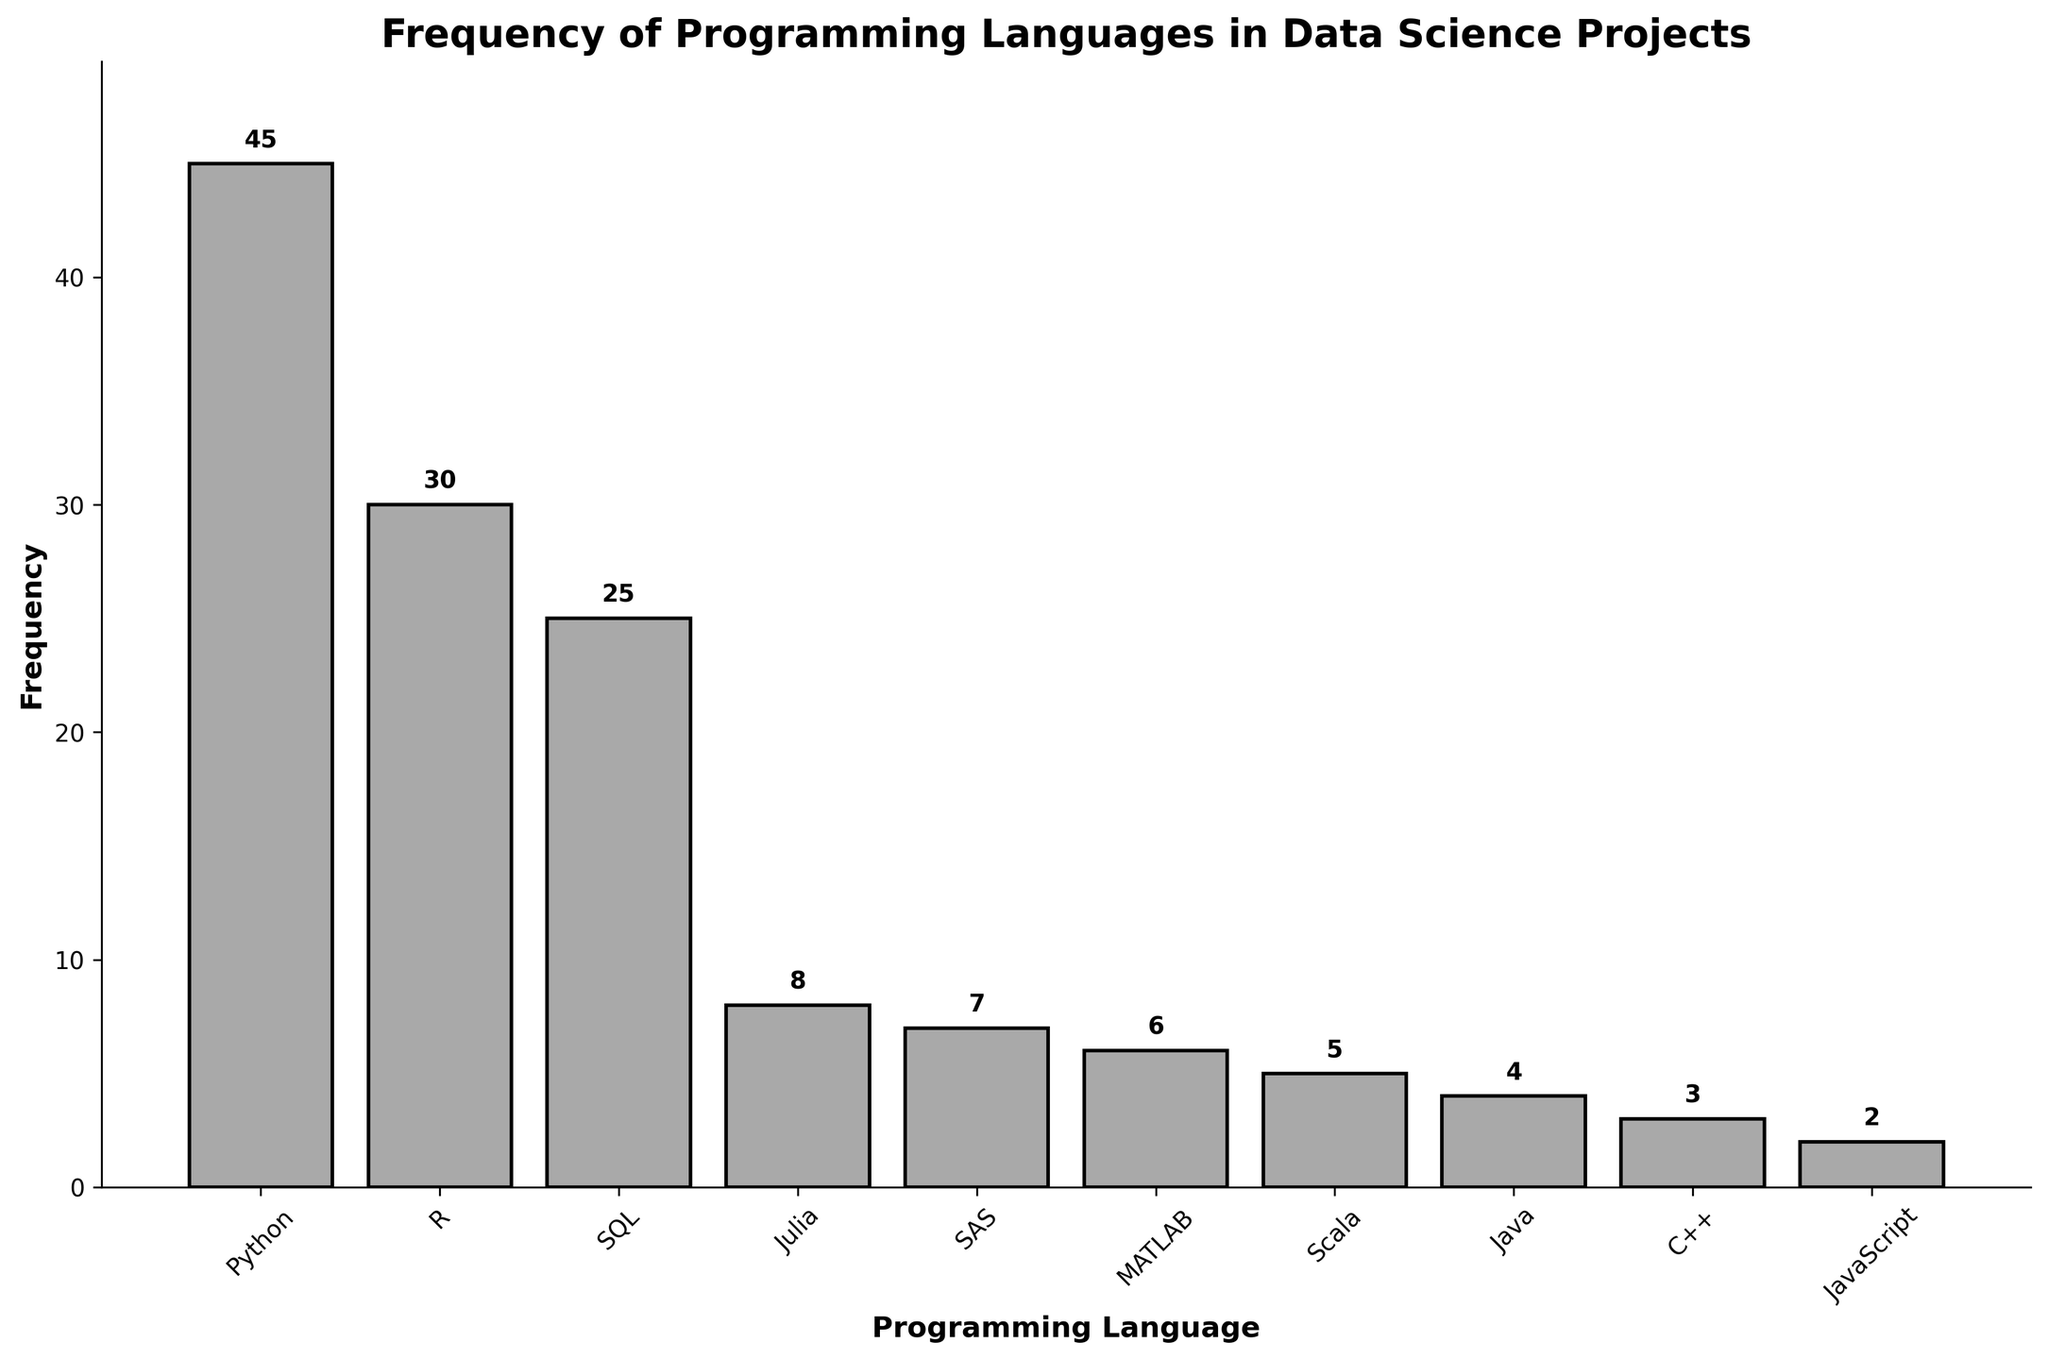What is the title of the histogram? Read the title text at the top of the histogram, which describes the content of the chart.
Answer: Frequency of Programming Languages in Data Science Projects How many programming languages are represented in the histogram? Count the number of different bars shown on the x-axis, each representing a programming language.
Answer: 10 Which programming language has the highest frequency? Look for the tallest bar in the histogram and read the corresponding programming language label on the x-axis.
Answer: Python What is the frequency of Java? Find the bar labeled "Java" on the x-axis and read its height value on the y-axis or the label above the bar.
Answer: 4 Which programming language has a frequency of 2? Identify the bar with a height of 2 and then read the corresponding programming language label on the x-axis.
Answer: JavaScript What is the difference in frequency between Python and R? Find the heights of the bars for Python and R, subtract the smaller value from the larger one (45 - 30).
Answer: 15 What is the total frequency of the top three programming languages combined? Add the frequencies of Python, R, and SQL (45 + 30 + 25).
Answer: 100 How many programming languages have a frequency lower than 10? Count the bars with a height (frequency) less than 10 by examining the y-axis scale.
Answer: 6 Which has a higher frequency: MATLAB or Scala? Compare the heights of the bars or the values shown above the bars for MATLAB and Scala.
Answer: MATLAB What percentage of the total frequency does C++ represent? Calculate the total frequency by summing all values, then find C++'s frequency as a fraction of the total and convert to percentage ((3 / (45 + 30 + 25 + 8 + 7 + 6 + 5 + 4 + 3 + 2)) * 100).
Answer: 2.17% 